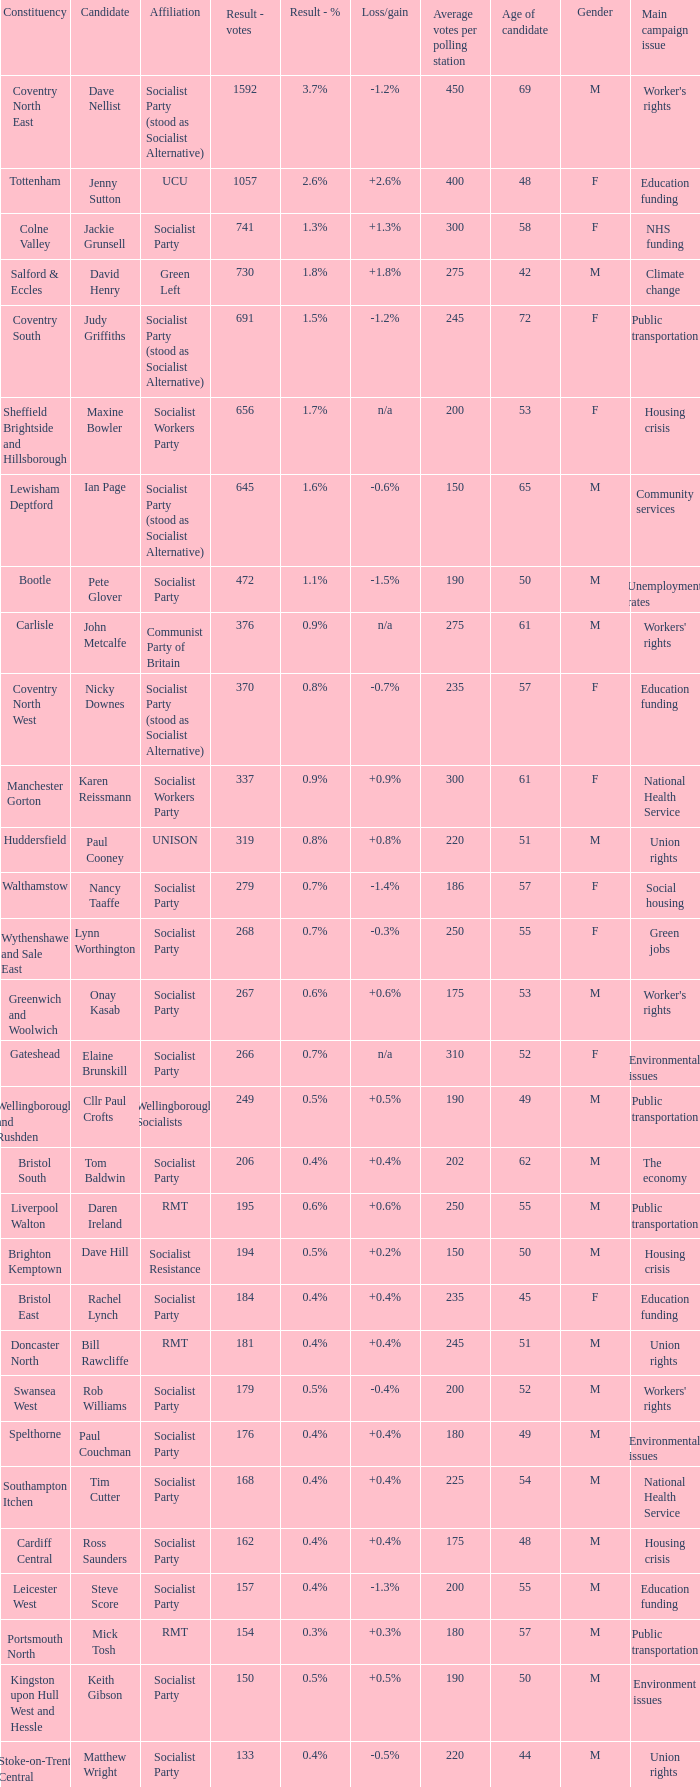What is every affiliation for candidate Daren Ireland? RMT. 